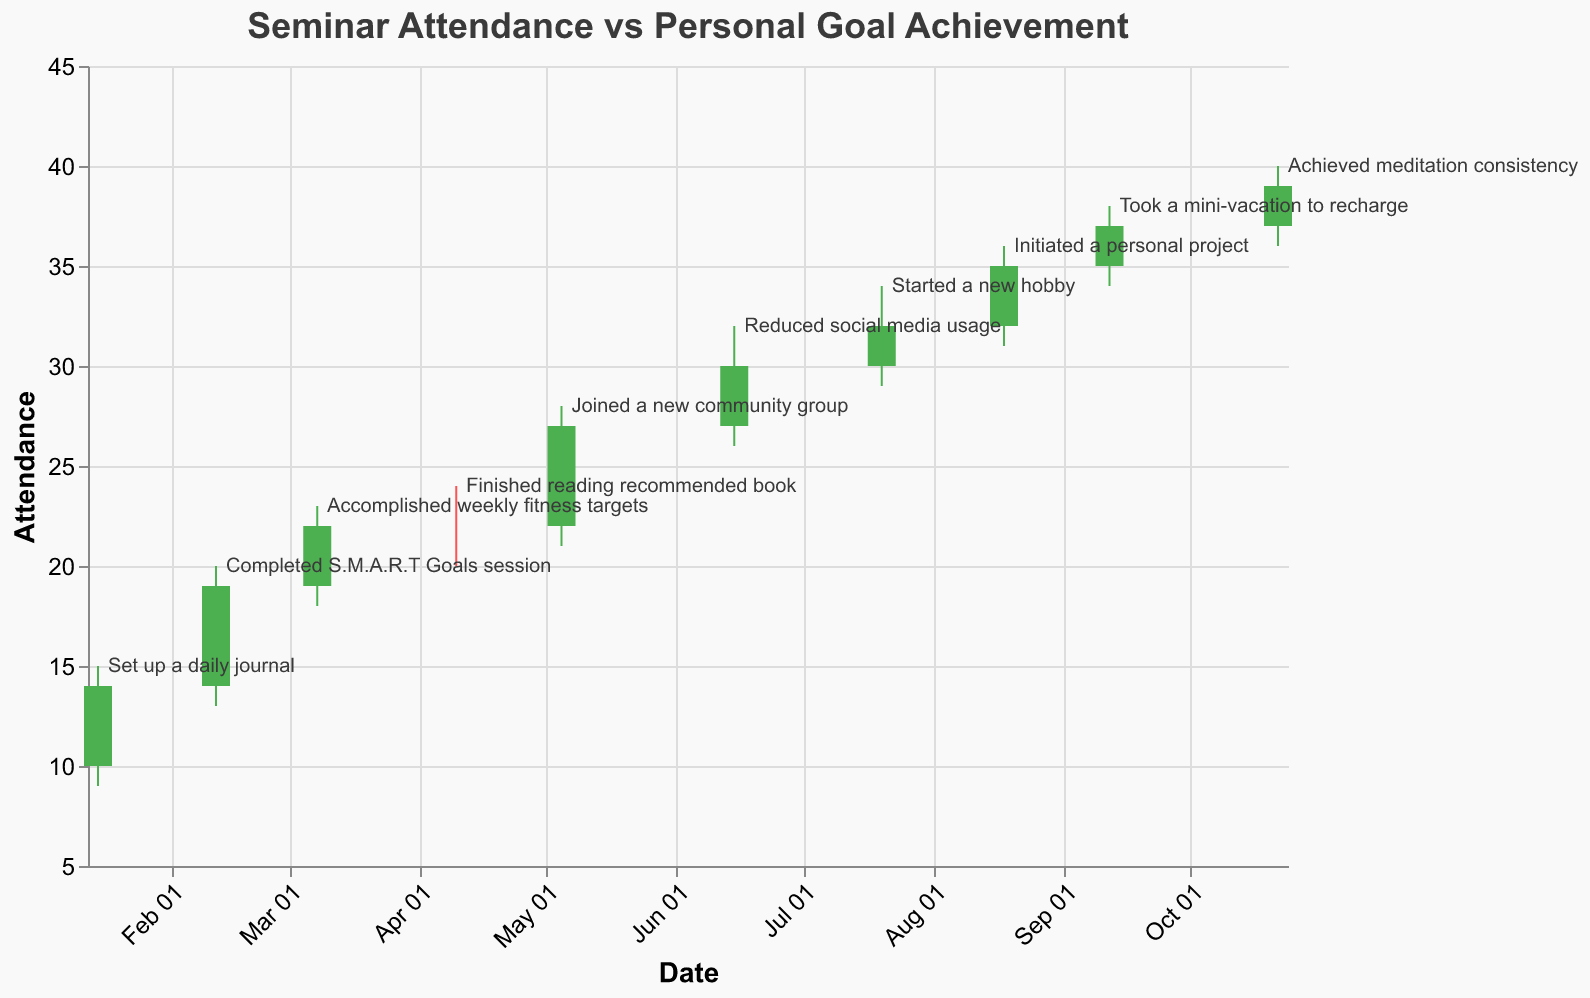What is the title of the figure? The title is usually displayed at the top center of the figure. In this case, it is "Seminar Attendance vs Personal Goal Achievement".
Answer: Seminar Attendance vs Personal Goal Achievement What axis represents the "Attendance" values? The "Attendance" values are represented on the y-axis, which is vertical and labeled accordingly.
Answer: y-axis How many data points are represented in the figure? Each data point corresponds to a date entry. There are ten entries in the dataset, so there are ten data points in the figure.
Answer: 10 Which milestone was achieved on 2023-05-05? Locate the data point for the date 2023-05-05. The associated milestone is labeled near the high value, "Joined a new community group".
Answer: Joined a new community group Which data point had the highest "Close" value, and what was this value? The highest "Close" value can be seen from the candlesticks. The highest "Close" value is 39 on 2023-10-22.
Answer: 39 on 2023-10-22 What was the seminar attendance range (High - Low) on 2023-06-15? The range is found by subtracting the Low value from the High value for the specified date. For 2023-06-15, the High is 32 and the Low is 26. The range is 32 - 26 = 6.
Answer: 6 Compare the "Open" and "Close" values for the date 2023-01-15. Was the attendance higher at the start or end? For 2023-01-15, the Open value is 10 and the Close value is 14. The attendance was higher at the end of the period.
Answer: End Which month showed the largest increase in attendance from Open to Close? Compare the difference (Close - Open) for all months. The largest increase is from 22 to 27 in May, with an increase of 5.
Answer: May What was the milestone achieved when the attendance "Open" value first reached 30? Find the data point where Open first equals 30, which is on 2023-07-20. The milestone achieved was "Started a new hobby".
Answer: Started a new hobby How many times did the attendance increase (Open < Close) over the year? Look at each candlestick color; green indicates an increase. There are 9 green candlesticks.
Answer: 9 